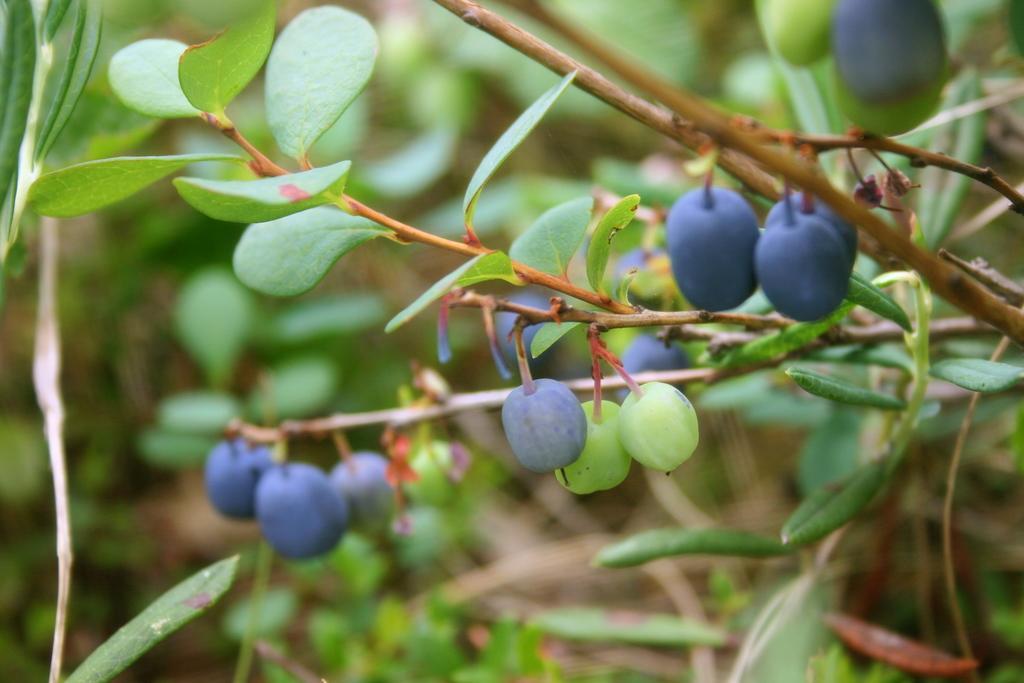How would you summarize this image in a sentence or two? In this picture I can see there are few berries attached to the stem and there are few leaves and the backdrop is blurred. 